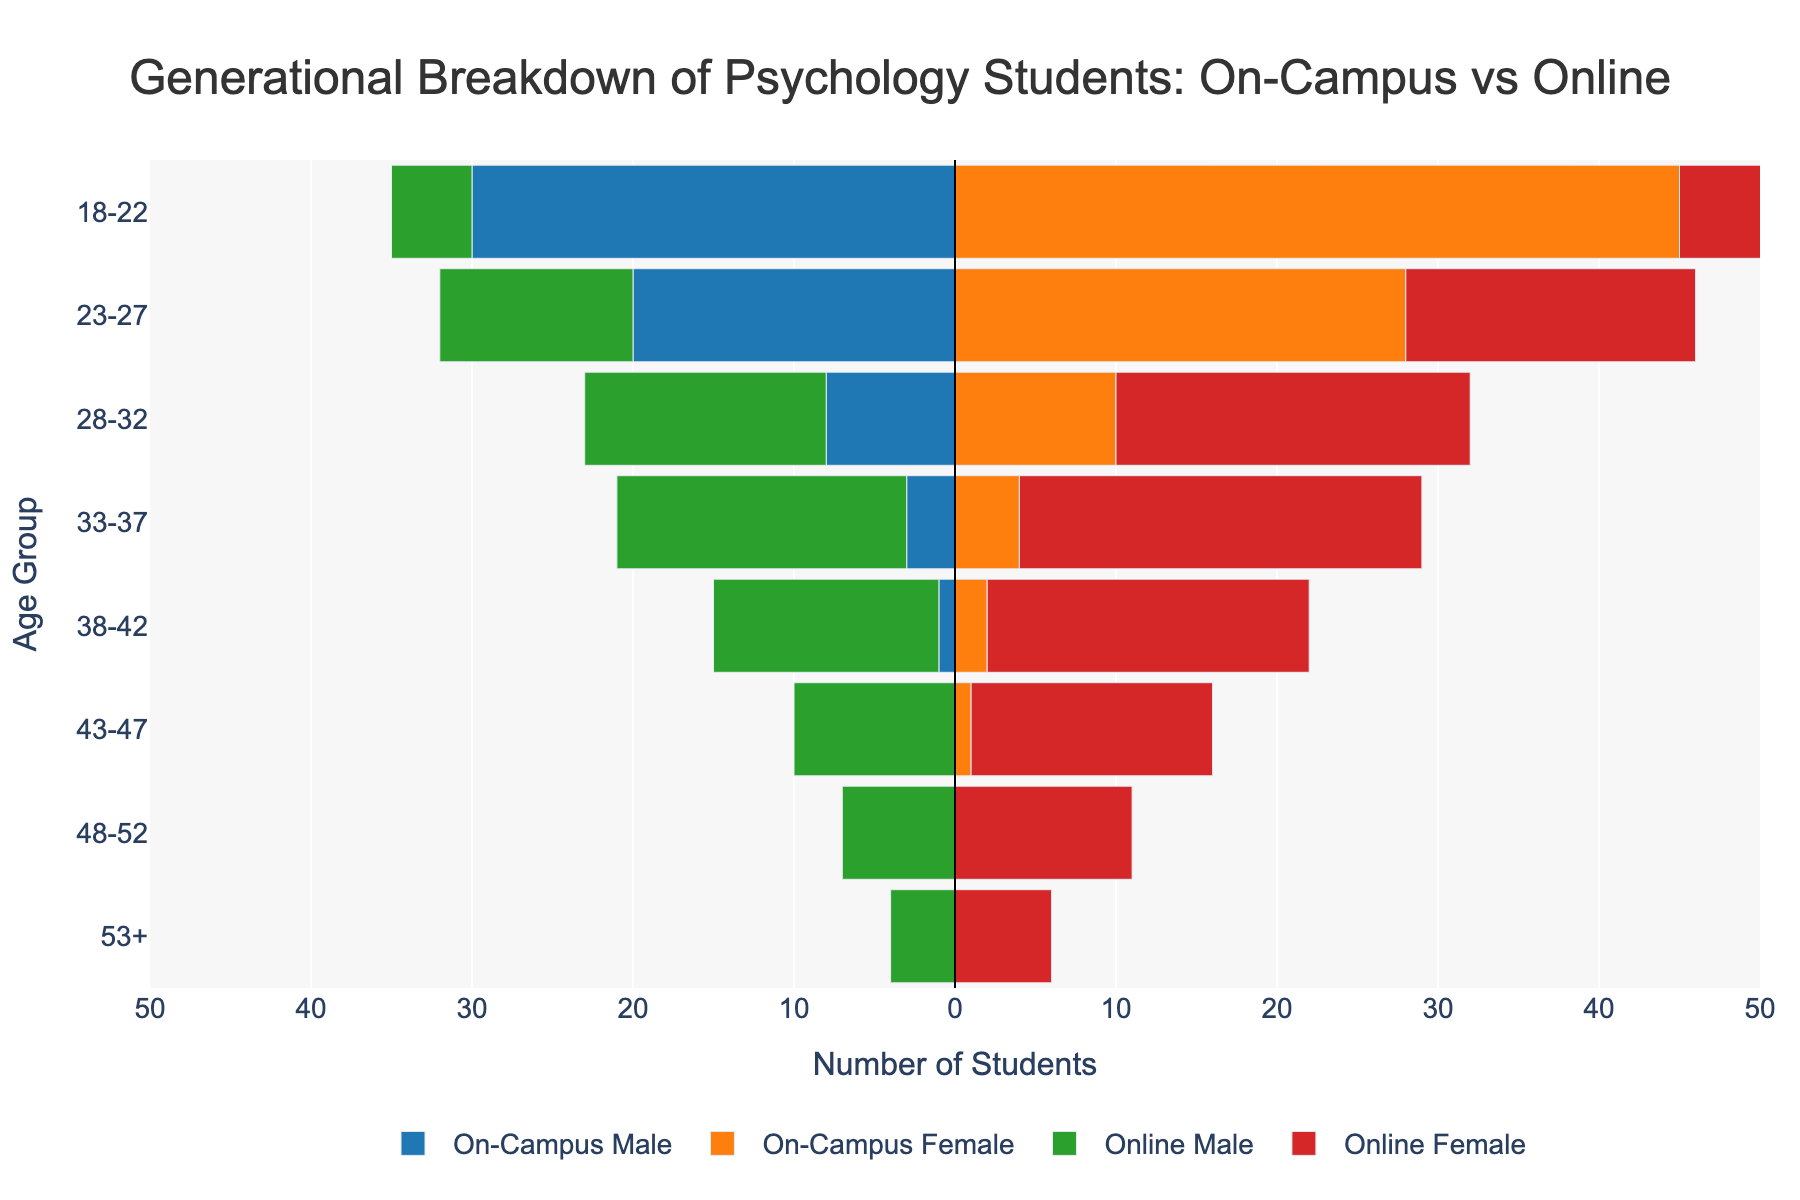What is the title of the figure? The title is located at the top center of the figure and reads, "Generational Breakdown of Psychology Students: On-Campus vs Online".
Answer: Generational Breakdown of Psychology Students: On-Campus vs Online Which age group has the highest number of on-campus male students? Look at the bars representing on-campus male students (blue) on the left side of the y-axis. The 18-22 age group has the longest bar, indicating it has the highest number.
Answer: 18-22 Which age group has more online male students than on-campus male students? Compare the length of the green bars (online male) to the blue bars (on-campus male) for each age group. Age groups 28-32, 33-37, 38-42, 43-47, 48-52, and 53+ have longer green bars compared to blue bars indicating more online male students.
Answer: 28-32, 33-37, 38-42, 43-47, 48-52, 53+ What is the total number of on-campus female students in the 23-27 age group? Refer to the orange bar for on-campus female students in the 23-27 age group. The bar's length indicates the value, which is 28.
Answer: 28 Between on-campus and online female students, which group has more students aged 33-37? Compare the length of the orange bar (on-campus female) with the length of the red bar (online female) for the 33-37 age group. The red bar is longer, indicating there are more online female students.
Answer: Online female How many more on-campus students aged 18-22 are there compared to online students of the same age group? Add the number of on-campus males (30) and females (45) for the 18-22 age group to get 75. Add the number of online males (5) and females (8) for the same age group to get 13. Subtract 13 from 75.
Answer: 62 What is the range of the x-axis? The x-axis range indicates the number of students, which spans from -50 to 50.
Answer: -50 to 50 Which age group has the smallest number of online male students? Look at the green bars on the right side of the y-axis. The 53+ age group has the shortest green bar, indicating 4 online male students.
Answer: 53+ Which age group has a larger proportion of online female students than on-campus female students? Compare the lengths of the red bars (online female) and the orange bars (on-campus female) within each age group. The age groups 28-32, 33-37, 38-42, 43-47, 48-52, and 53+ have more online female students as indicated by the longer red bars.
Answer: 28-32, 33-37, 38-42, 43-47, 48-52, 53+ How do the number of on-campus male and on-campus female students aged 18-22 compare? Compare the length of the blue bar (on-campus male) to the length of the orange bar (on-campus female) for 18-22. On-campus female students are more numerous, with the length of the orange bar representing 45 students compared to 30 for the blue bar.
Answer: On-campus female students are more 